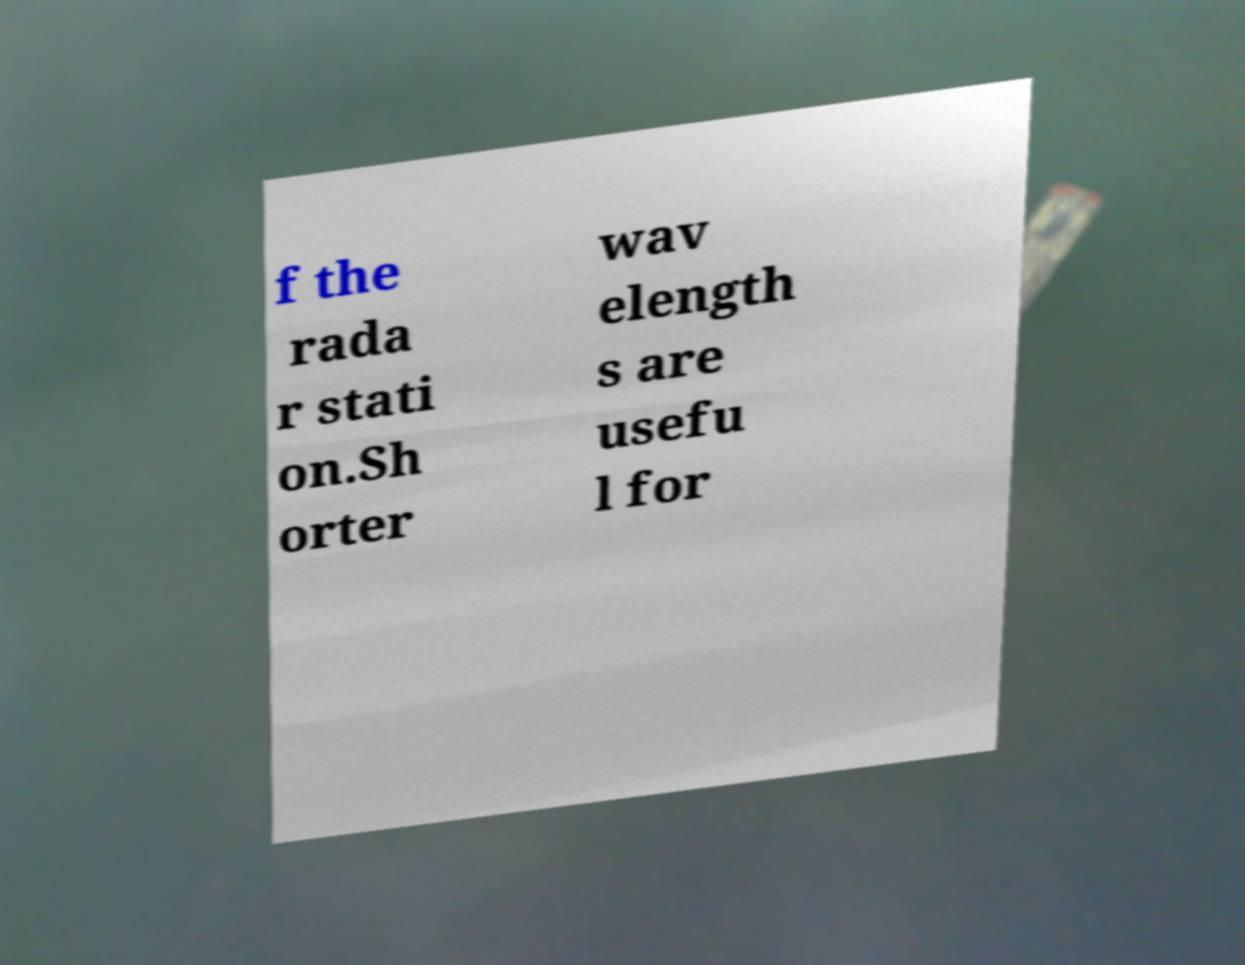What messages or text are displayed in this image? I need them in a readable, typed format. f the rada r stati on.Sh orter wav elength s are usefu l for 